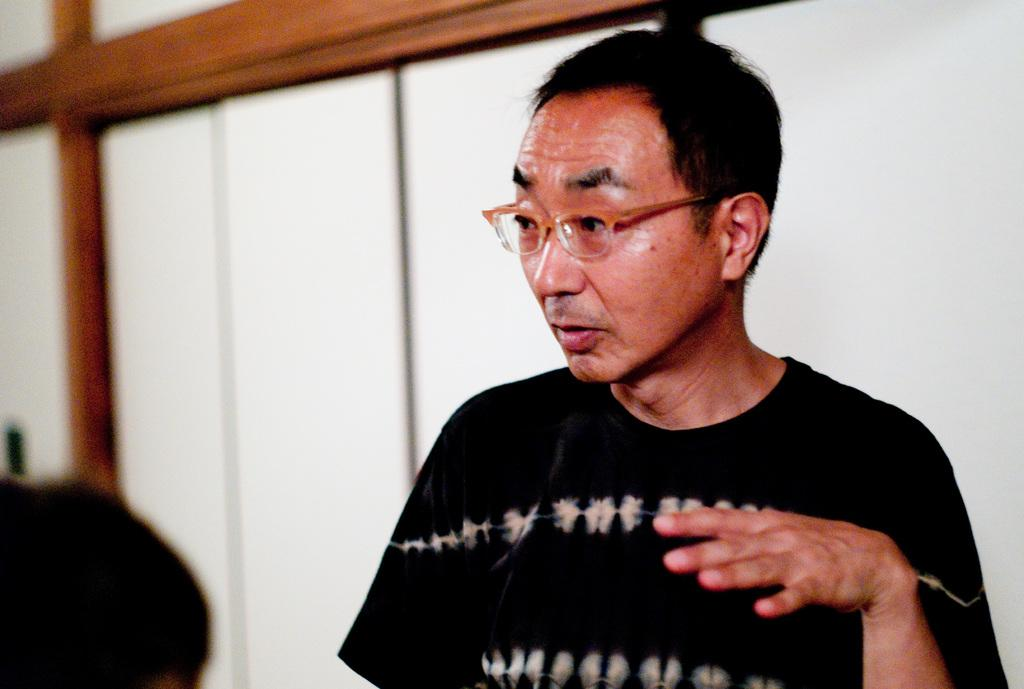What is the main subject of the image? There is a person standing in the image. What is the person in the image doing? The person is looking to the left side. Can you describe the other person in the image? There is another person beside the first person. What can be seen in the background of the image? There are cupboards in the background of the image. What type of furniture is the person touching in the image? There is no furniture present in the image for the person to touch. 